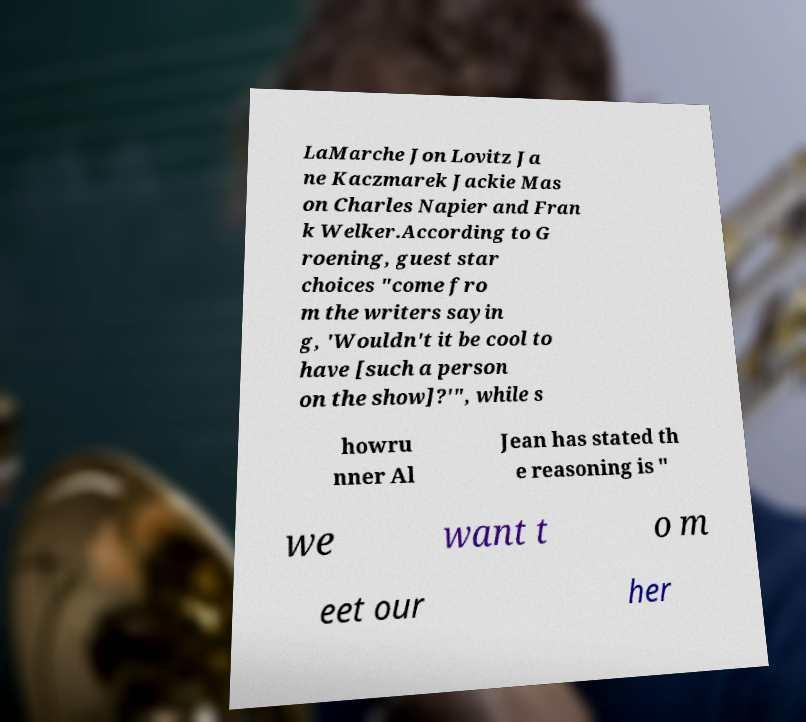Please read and relay the text visible in this image. What does it say? LaMarche Jon Lovitz Ja ne Kaczmarek Jackie Mas on Charles Napier and Fran k Welker.According to G roening, guest star choices "come fro m the writers sayin g, 'Wouldn't it be cool to have [such a person on the show]?'", while s howru nner Al Jean has stated th e reasoning is " we want t o m eet our her 